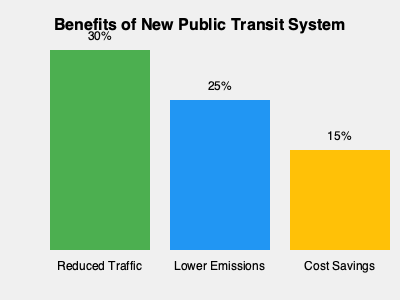Based on the infographic, which benefit of the new public transportation system shows the highest percentage improvement, and how much higher is it compared to the lowest percentage improvement? To answer this question, we need to follow these steps:

1. Identify the benefits and their corresponding percentages:
   - Reduced Traffic: 30%
   - Lower Emissions: 25%
   - Cost Savings: 15%

2. Determine the highest percentage improvement:
   The highest percentage is 30% for Reduced Traffic.

3. Determine the lowest percentage improvement:
   The lowest percentage is 15% for Cost Savings.

4. Calculate the difference between the highest and lowest percentages:
   $30\% - 15\% = 15\%$

Therefore, Reduced Traffic shows the highest percentage improvement at 30%, which is 15 percentage points higher than the lowest improvement of 15% for Cost Savings.
Answer: Reduced Traffic; 15 percentage points higher 